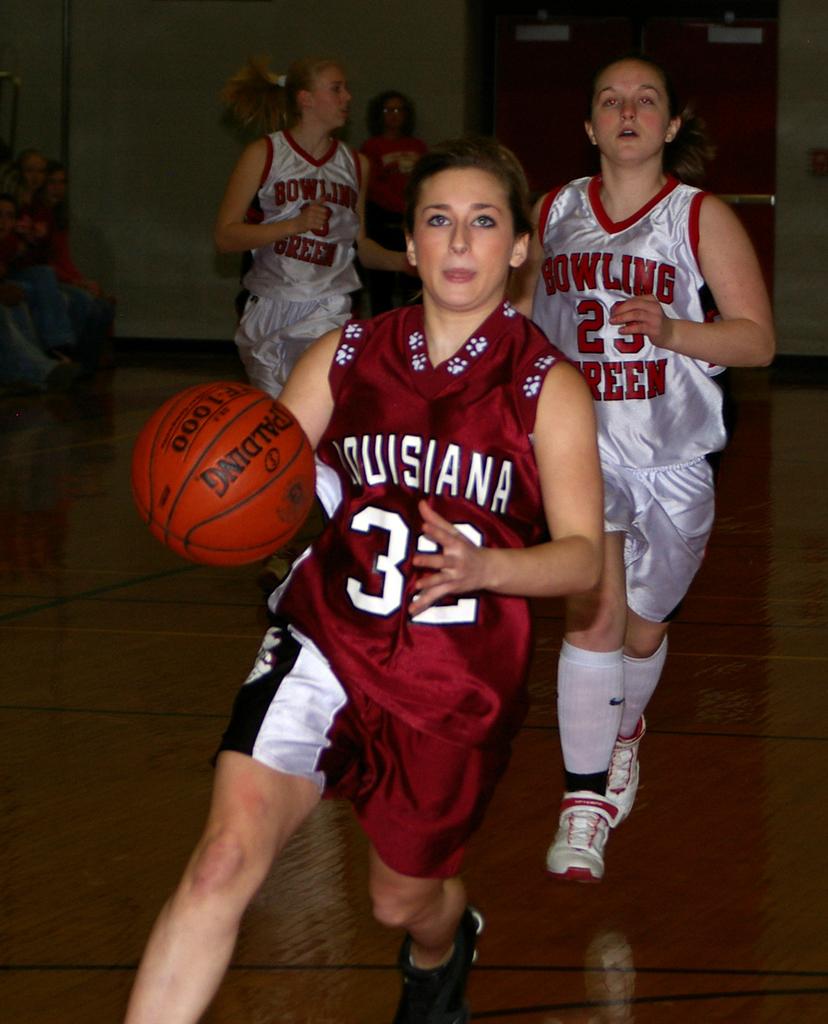Where does the dribbler attend college?
Offer a terse response. Louisiana. Which school do these basketball players represent?
Offer a terse response. Louisiana. 